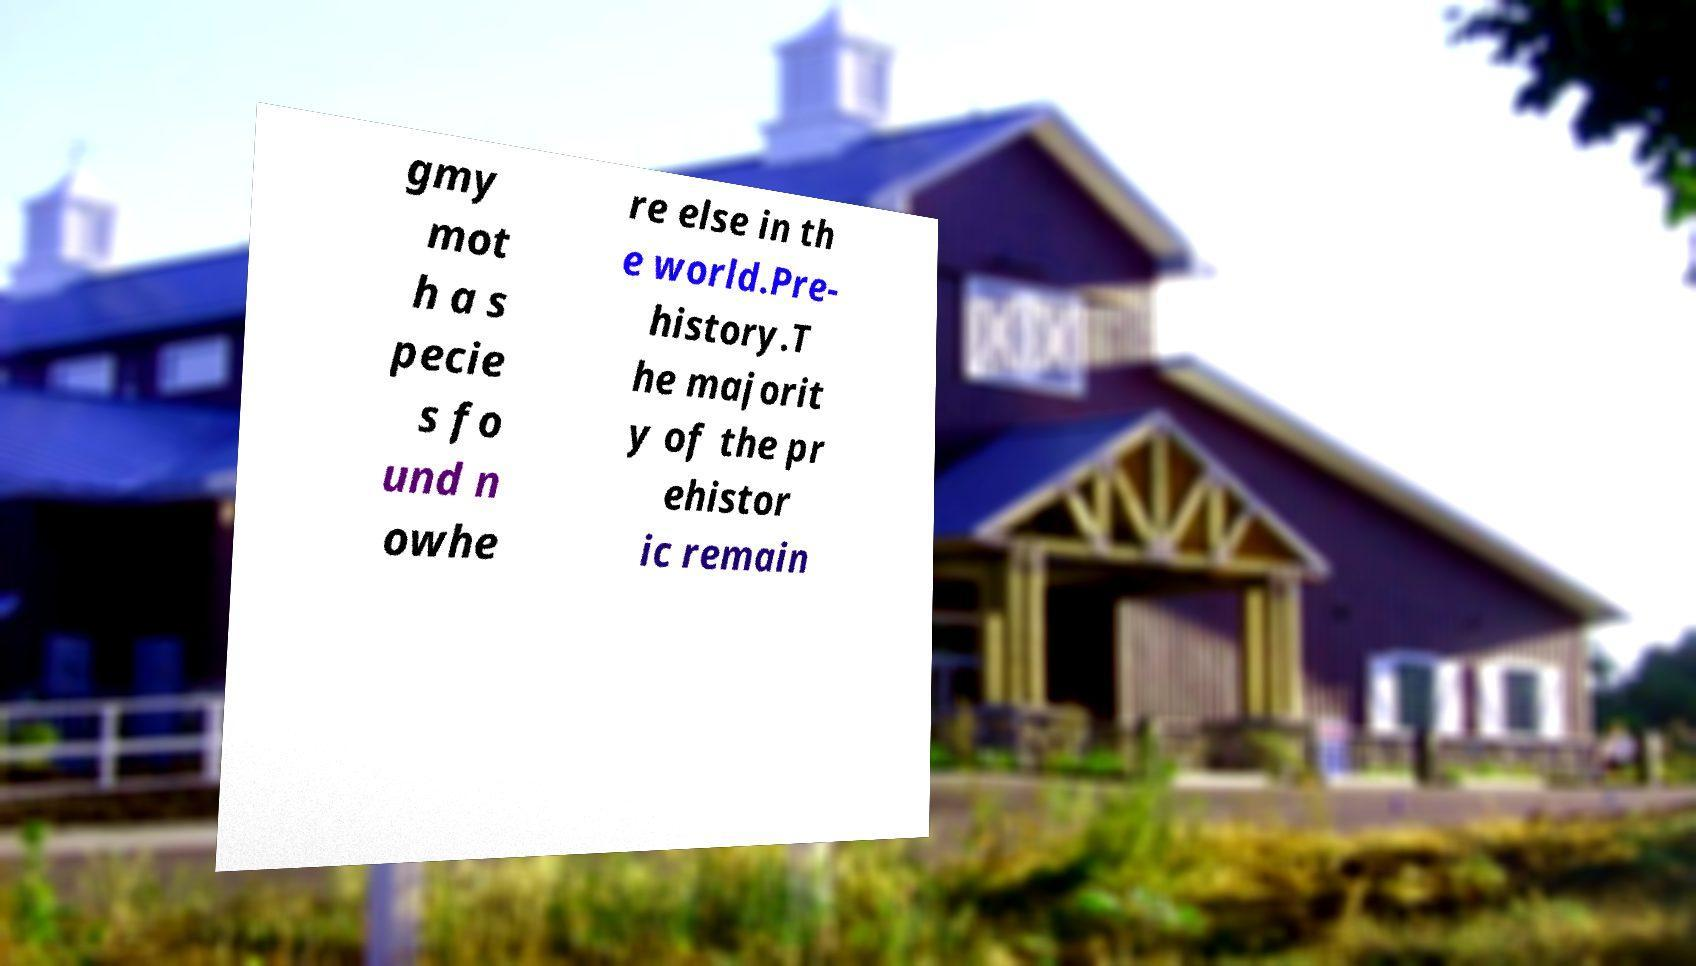Can you read and provide the text displayed in the image?This photo seems to have some interesting text. Can you extract and type it out for me? gmy mot h a s pecie s fo und n owhe re else in th e world.Pre- history.T he majorit y of the pr ehistor ic remain 